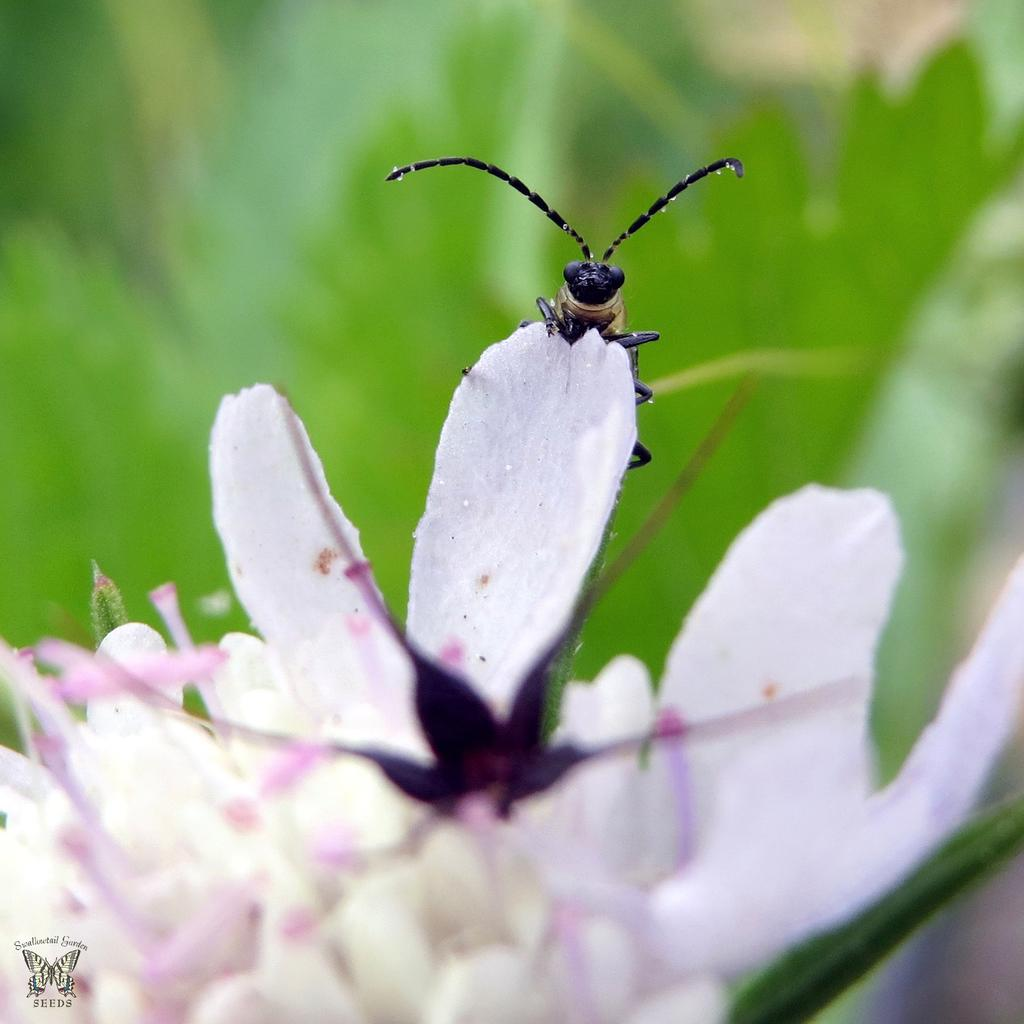What is present in the image? There is an insect in the image. Can you describe the insect? The insect is black in color. Where is the insect located? The insect is on a flower. What color is the flower? The flower is in light pink color. What can be seen in the background of the image? There is a green color background in the image. Is there a garden exchange happening in the image? There is no mention of a garden or exchange in the image; it features an insect on a flower with a green background. 